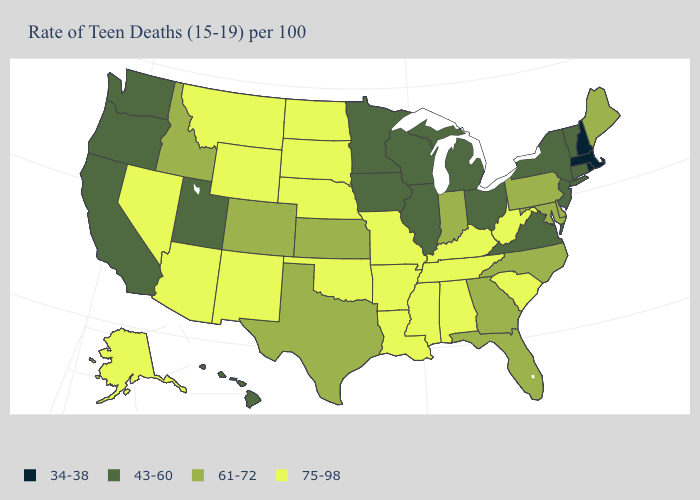Name the states that have a value in the range 34-38?
Keep it brief. Massachusetts, New Hampshire, Rhode Island. What is the value of Tennessee?
Keep it brief. 75-98. Does the map have missing data?
Be succinct. No. What is the value of Alabama?
Keep it brief. 75-98. Name the states that have a value in the range 75-98?
Concise answer only. Alabama, Alaska, Arizona, Arkansas, Kentucky, Louisiana, Mississippi, Missouri, Montana, Nebraska, Nevada, New Mexico, North Dakota, Oklahoma, South Carolina, South Dakota, Tennessee, West Virginia, Wyoming. Name the states that have a value in the range 61-72?
Give a very brief answer. Colorado, Delaware, Florida, Georgia, Idaho, Indiana, Kansas, Maine, Maryland, North Carolina, Pennsylvania, Texas. Among the states that border New Mexico , does Utah have the lowest value?
Keep it brief. Yes. Name the states that have a value in the range 75-98?
Be succinct. Alabama, Alaska, Arizona, Arkansas, Kentucky, Louisiana, Mississippi, Missouri, Montana, Nebraska, Nevada, New Mexico, North Dakota, Oklahoma, South Carolina, South Dakota, Tennessee, West Virginia, Wyoming. Name the states that have a value in the range 34-38?
Keep it brief. Massachusetts, New Hampshire, Rhode Island. What is the value of Kansas?
Write a very short answer. 61-72. Name the states that have a value in the range 43-60?
Keep it brief. California, Connecticut, Hawaii, Illinois, Iowa, Michigan, Minnesota, New Jersey, New York, Ohio, Oregon, Utah, Vermont, Virginia, Washington, Wisconsin. What is the value of Kansas?
Write a very short answer. 61-72. Is the legend a continuous bar?
Answer briefly. No. Does the map have missing data?
Short answer required. No. Name the states that have a value in the range 34-38?
Write a very short answer. Massachusetts, New Hampshire, Rhode Island. 